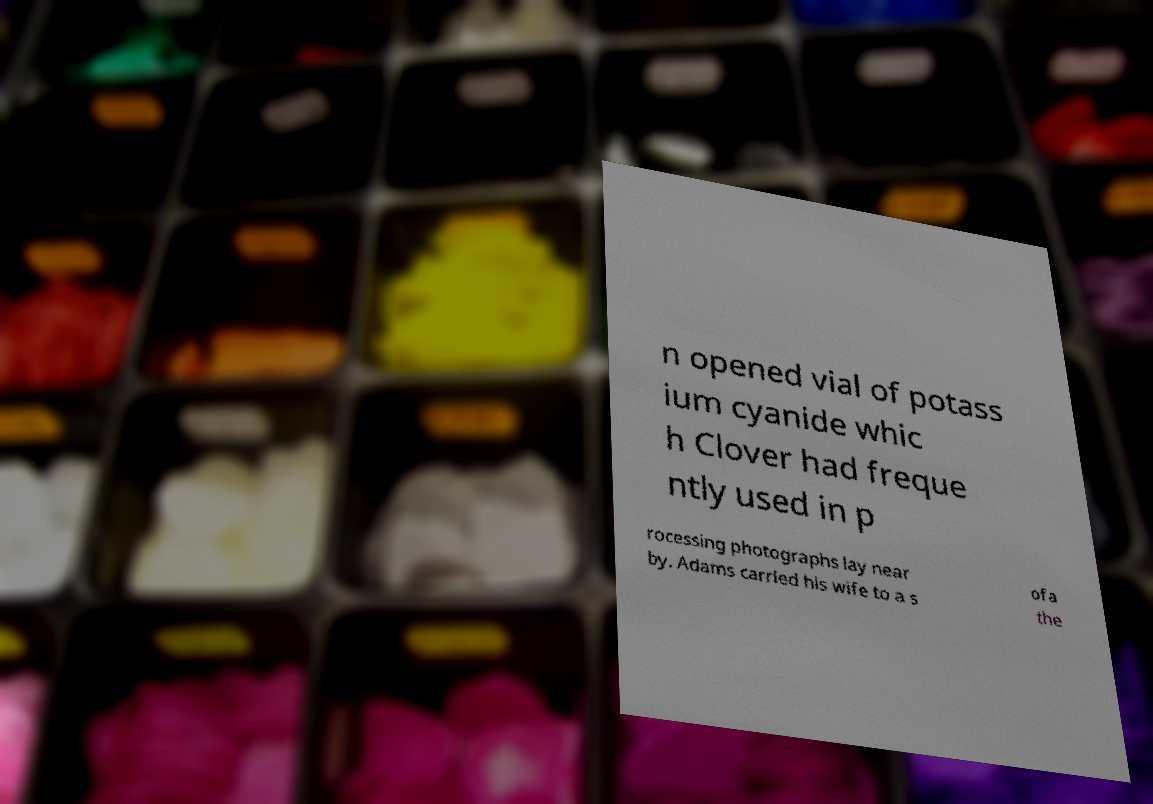Please read and relay the text visible in this image. What does it say? n opened vial of potass ium cyanide whic h Clover had freque ntly used in p rocessing photographs lay near by. Adams carried his wife to a s ofa the 